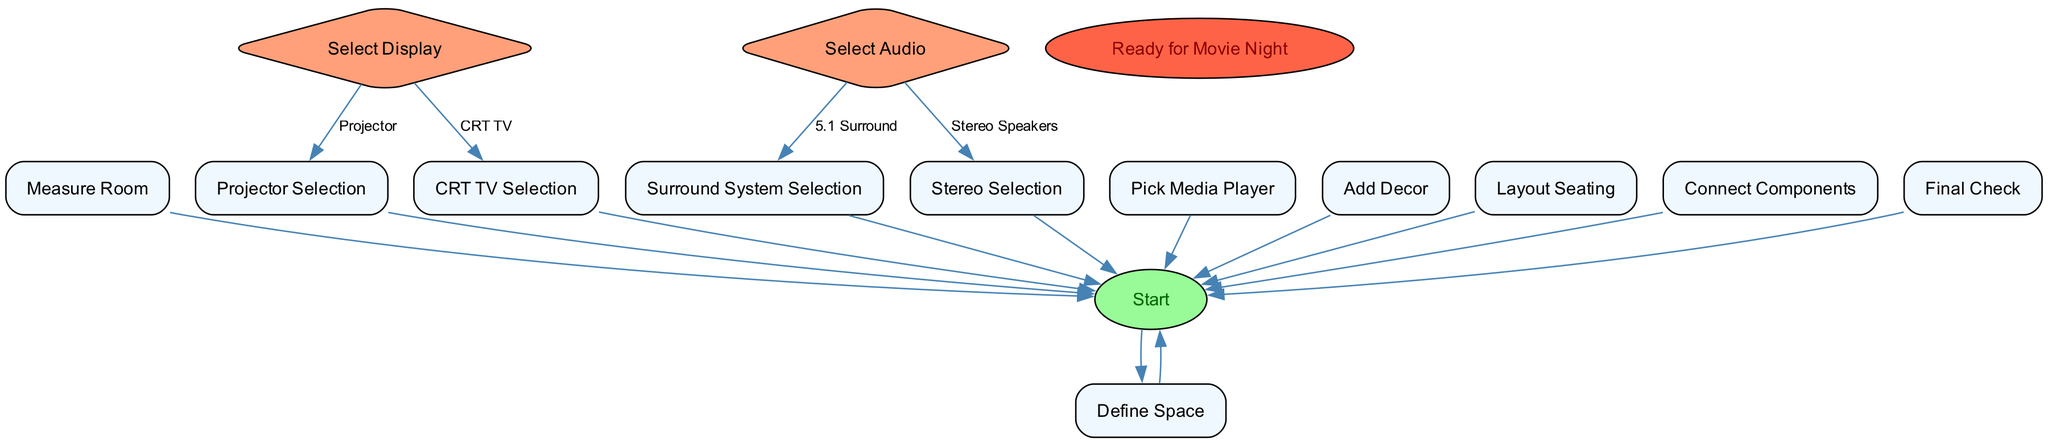What is the first step in the flowchart? The first step is labeled "Start," indicating the beginning of the process for setting up a '90s themed home theater system.
Answer: Start How many decision nodes are present in the flowchart? There are two decision nodes in the flowchart: one for selecting the display type (Projector or CRT TV) and another for selecting the audio system (5.1 Surround or Stereo Speakers).
Answer: 2 What display options are available according to the flowchart? The flowchart presents two options for the display: a Projector or a CRT TV, indicating the choices available at that stage of the setup.
Answer: Projector, CRT TV What comes after "Measure Room"? After "Measure Room," the next step is "Select Display," indicating the progression in the setup process.
Answer: Select Display What is the final step indicated in the flowchart? The final step labeled in the flowchart is "Ready for Movie Night," indicating the completion of the home theater setup.
Answer: Ready for Movie Night What audio system options can be chosen? The flowchart presents two audio system options: a 5.1 surround sound system or classic stereo speakers, indicating choices for audio selection.
Answer: 5.1 Surround, Stereo Speakers Which equipment selection follows after choosing a CRT TV? If a CRT TV is chosen, the following step is "CRT TV Selection," which provides further guidance on which specific TV to select.
Answer: CRT TV Selection How many total process nodes are there in the flowchart? To find the total number of process nodes, we count all the nodes of type 'process' which includes defining the space, measuring the room, selecting the display, and others leading to the final setup. There are seven process nodes.
Answer: 7 